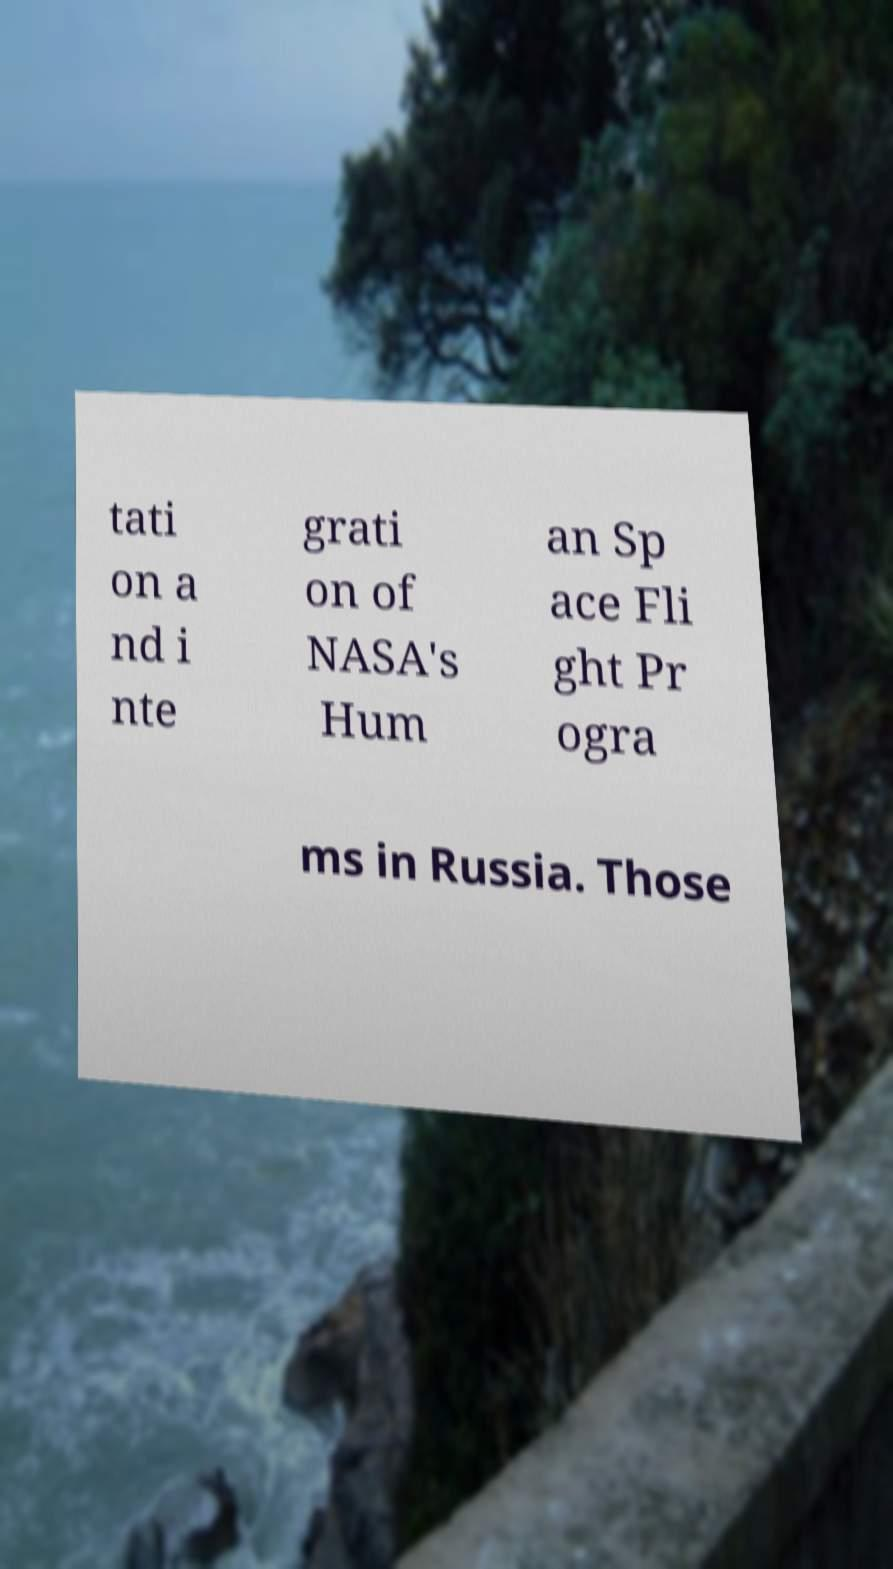Could you assist in decoding the text presented in this image and type it out clearly? tati on a nd i nte grati on of NASA's Hum an Sp ace Fli ght Pr ogra ms in Russia. Those 